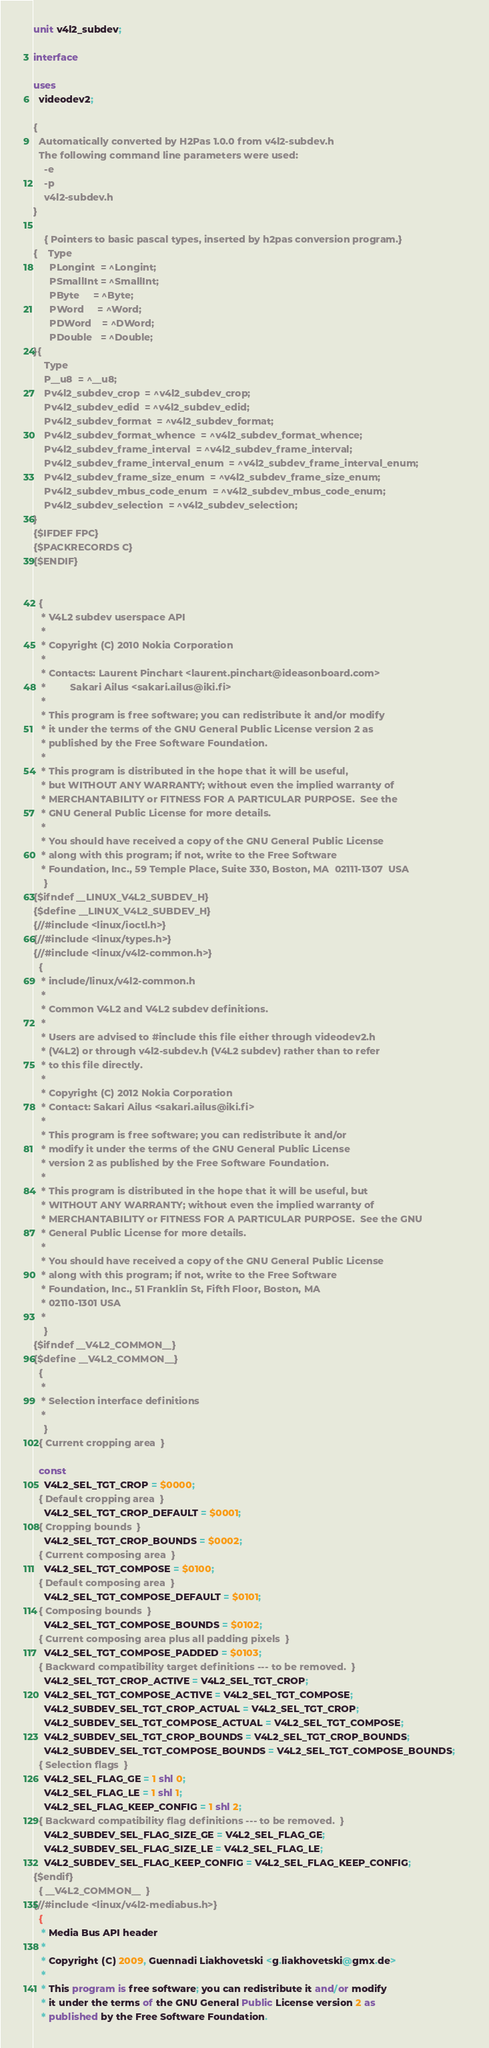Convert code to text. <code><loc_0><loc_0><loc_500><loc_500><_Pascal_>unit v4l2_subdev;

interface

uses
  videodev2;

{
  Automatically converted by H2Pas 1.0.0 from v4l2-subdev.h
  The following command line parameters were used:
    -e
    -p
    v4l2-subdev.h
}

    { Pointers to basic pascal types, inserted by h2pas conversion program.}
{    Type
      PLongint  = ^Longint;
      PSmallInt = ^SmallInt;
      PByte     = ^Byte;
      PWord     = ^Word;
      PDWord    = ^DWord;
      PDouble   = ^Double;
}{
    Type
    P__u8  = ^__u8;
    Pv4l2_subdev_crop  = ^v4l2_subdev_crop;
    Pv4l2_subdev_edid  = ^v4l2_subdev_edid;
    Pv4l2_subdev_format  = ^v4l2_subdev_format;
    Pv4l2_subdev_format_whence  = ^v4l2_subdev_format_whence;
    Pv4l2_subdev_frame_interval  = ^v4l2_subdev_frame_interval;
    Pv4l2_subdev_frame_interval_enum  = ^v4l2_subdev_frame_interval_enum;
    Pv4l2_subdev_frame_size_enum  = ^v4l2_subdev_frame_size_enum;
    Pv4l2_subdev_mbus_code_enum  = ^v4l2_subdev_mbus_code_enum;
    Pv4l2_subdev_selection  = ^v4l2_subdev_selection;
}
{$IFDEF FPC}
{$PACKRECORDS C}
{$ENDIF}


  {
   * V4L2 subdev userspace API
   *
   * Copyright (C) 2010 Nokia Corporation
   *
   * Contacts: Laurent Pinchart <laurent.pinchart@ideasonboard.com>
   *	     Sakari Ailus <sakari.ailus@iki.fi>
   *
   * This program is free software; you can redistribute it and/or modify
   * it under the terms of the GNU General Public License version 2 as
   * published by the Free Software Foundation.
   *
   * This program is distributed in the hope that it will be useful,
   * but WITHOUT ANY WARRANTY; without even the implied warranty of
   * MERCHANTABILITY or FITNESS FOR A PARTICULAR PURPOSE.  See the
   * GNU General Public License for more details.
   *
   * You should have received a copy of the GNU General Public License
   * along with this program; if not, write to the Free Software
   * Foundation, Inc., 59 Temple Place, Suite 330, Boston, MA  02111-1307  USA
    }
{$ifndef __LINUX_V4L2_SUBDEV_H}
{$define __LINUX_V4L2_SUBDEV_H}  
{//#include <linux/ioctl.h>}
{//#include <linux/types.h>}
{//#include <linux/v4l2-common.h>}
  {
   * include/linux/v4l2-common.h
   *
   * Common V4L2 and V4L2 subdev definitions.
   *
   * Users are advised to #include this file either through videodev2.h
   * (V4L2) or through v4l2-subdev.h (V4L2 subdev) rather than to refer
   * to this file directly.
   *
   * Copyright (C) 2012 Nokia Corporation
   * Contact: Sakari Ailus <sakari.ailus@iki.fi>
   *
   * This program is free software; you can redistribute it and/or
   * modify it under the terms of the GNU General Public License
   * version 2 as published by the Free Software Foundation.
   *
   * This program is distributed in the hope that it will be useful, but
   * WITHOUT ANY WARRANTY; without even the implied warranty of
   * MERCHANTABILITY or FITNESS FOR A PARTICULAR PURPOSE.  See the GNU
   * General Public License for more details.
   *
   * You should have received a copy of the GNU General Public License
   * along with this program; if not, write to the Free Software
   * Foundation, Inc., 51 Franklin St, Fifth Floor, Boston, MA
   * 02110-1301 USA
   *
    }
{$ifndef __V4L2_COMMON__}
{$define __V4L2_COMMON__}  
  {
   *
   * Selection interface definitions
   *
    }
  { Current cropping area  }

  const
    V4L2_SEL_TGT_CROP = $0000;    
  { Default cropping area  }
    V4L2_SEL_TGT_CROP_DEFAULT = $0001;    
  { Cropping bounds  }
    V4L2_SEL_TGT_CROP_BOUNDS = $0002;    
  { Current composing area  }
    V4L2_SEL_TGT_COMPOSE = $0100;    
  { Default composing area  }
    V4L2_SEL_TGT_COMPOSE_DEFAULT = $0101;    
  { Composing bounds  }
    V4L2_SEL_TGT_COMPOSE_BOUNDS = $0102;    
  { Current composing area plus all padding pixels  }
    V4L2_SEL_TGT_COMPOSE_PADDED = $0103;    
  { Backward compatibility target definitions --- to be removed.  }
    V4L2_SEL_TGT_CROP_ACTIVE = V4L2_SEL_TGT_CROP;    
    V4L2_SEL_TGT_COMPOSE_ACTIVE = V4L2_SEL_TGT_COMPOSE;    
    V4L2_SUBDEV_SEL_TGT_CROP_ACTUAL = V4L2_SEL_TGT_CROP;    
    V4L2_SUBDEV_SEL_TGT_COMPOSE_ACTUAL = V4L2_SEL_TGT_COMPOSE;    
    V4L2_SUBDEV_SEL_TGT_CROP_BOUNDS = V4L2_SEL_TGT_CROP_BOUNDS;    
    V4L2_SUBDEV_SEL_TGT_COMPOSE_BOUNDS = V4L2_SEL_TGT_COMPOSE_BOUNDS;    
  { Selection flags  }
    V4L2_SEL_FLAG_GE = 1 shl 0;    
    V4L2_SEL_FLAG_LE = 1 shl 1;    
    V4L2_SEL_FLAG_KEEP_CONFIG = 1 shl 2;    
  { Backward compatibility flag definitions --- to be removed.  }
    V4L2_SUBDEV_SEL_FLAG_SIZE_GE = V4L2_SEL_FLAG_GE;    
    V4L2_SUBDEV_SEL_FLAG_SIZE_LE = V4L2_SEL_FLAG_LE;    
    V4L2_SUBDEV_SEL_FLAG_KEEP_CONFIG = V4L2_SEL_FLAG_KEEP_CONFIG;    
{$endif}
  { __V4L2_COMMON__  }
{//#include <linux/v4l2-mediabus.h>}
  {
   * Media Bus API header
   *
   * Copyright (C) 2009, Guennadi Liakhovetski <g.liakhovetski@gmx.de>
   *
   * This program is free software; you can redistribute it and/or modify
   * it under the terms of the GNU General Public License version 2 as
   * published by the Free Software Foundation.</code> 